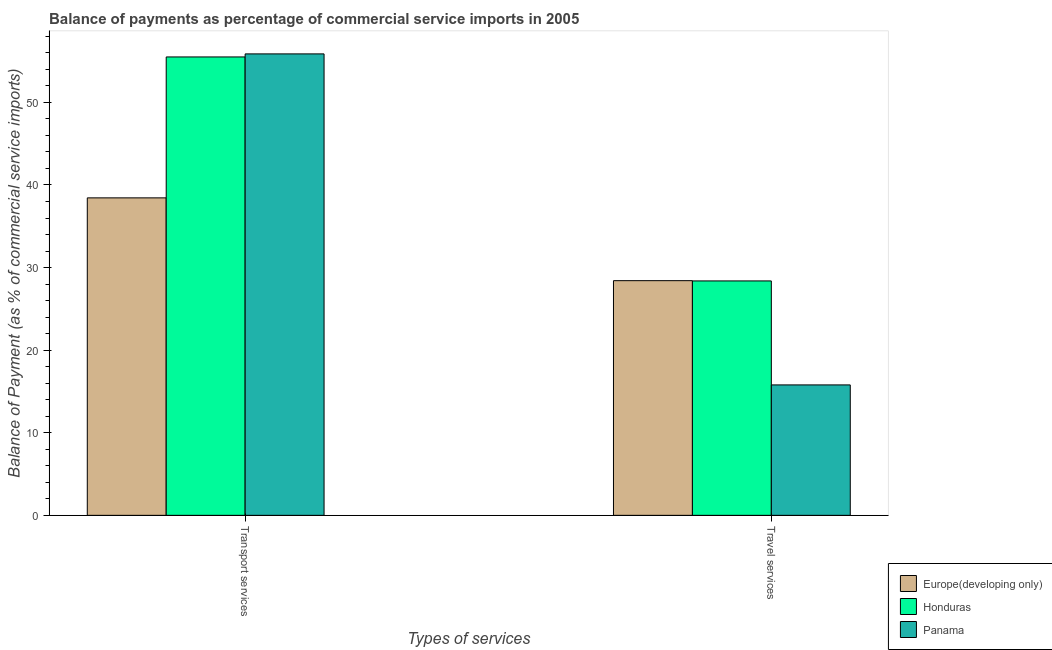How many different coloured bars are there?
Your answer should be compact. 3. Are the number of bars per tick equal to the number of legend labels?
Keep it short and to the point. Yes. Are the number of bars on each tick of the X-axis equal?
Your response must be concise. Yes. How many bars are there on the 2nd tick from the left?
Ensure brevity in your answer.  3. How many bars are there on the 1st tick from the right?
Provide a succinct answer. 3. What is the label of the 1st group of bars from the left?
Your answer should be compact. Transport services. What is the balance of payments of travel services in Panama?
Provide a short and direct response. 15.79. Across all countries, what is the maximum balance of payments of transport services?
Your answer should be very brief. 55.87. Across all countries, what is the minimum balance of payments of transport services?
Your response must be concise. 38.44. In which country was the balance of payments of travel services maximum?
Ensure brevity in your answer.  Europe(developing only). In which country was the balance of payments of transport services minimum?
Keep it short and to the point. Europe(developing only). What is the total balance of payments of travel services in the graph?
Your answer should be very brief. 72.59. What is the difference between the balance of payments of transport services in Europe(developing only) and that in Panama?
Your response must be concise. -17.43. What is the difference between the balance of payments of travel services in Europe(developing only) and the balance of payments of transport services in Honduras?
Your answer should be compact. -27.09. What is the average balance of payments of transport services per country?
Ensure brevity in your answer.  49.94. What is the difference between the balance of payments of travel services and balance of payments of transport services in Panama?
Give a very brief answer. -40.08. What is the ratio of the balance of payments of travel services in Panama to that in Honduras?
Your response must be concise. 0.56. Is the balance of payments of travel services in Europe(developing only) less than that in Honduras?
Your response must be concise. No. In how many countries, is the balance of payments of travel services greater than the average balance of payments of travel services taken over all countries?
Your answer should be very brief. 2. What does the 1st bar from the left in Transport services represents?
Provide a succinct answer. Europe(developing only). What does the 3rd bar from the right in Transport services represents?
Your response must be concise. Europe(developing only). Are all the bars in the graph horizontal?
Offer a terse response. No. How many countries are there in the graph?
Your response must be concise. 3. What is the difference between two consecutive major ticks on the Y-axis?
Provide a short and direct response. 10. Does the graph contain any zero values?
Offer a terse response. No. Does the graph contain grids?
Your answer should be very brief. No. How are the legend labels stacked?
Offer a terse response. Vertical. What is the title of the graph?
Offer a very short reply. Balance of payments as percentage of commercial service imports in 2005. What is the label or title of the X-axis?
Your answer should be very brief. Types of services. What is the label or title of the Y-axis?
Make the answer very short. Balance of Payment (as % of commercial service imports). What is the Balance of Payment (as % of commercial service imports) of Europe(developing only) in Transport services?
Your answer should be compact. 38.44. What is the Balance of Payment (as % of commercial service imports) of Honduras in Transport services?
Your response must be concise. 55.5. What is the Balance of Payment (as % of commercial service imports) in Panama in Transport services?
Ensure brevity in your answer.  55.87. What is the Balance of Payment (as % of commercial service imports) in Europe(developing only) in Travel services?
Give a very brief answer. 28.42. What is the Balance of Payment (as % of commercial service imports) of Honduras in Travel services?
Offer a terse response. 28.38. What is the Balance of Payment (as % of commercial service imports) in Panama in Travel services?
Give a very brief answer. 15.79. Across all Types of services, what is the maximum Balance of Payment (as % of commercial service imports) in Europe(developing only)?
Offer a terse response. 38.44. Across all Types of services, what is the maximum Balance of Payment (as % of commercial service imports) in Honduras?
Give a very brief answer. 55.5. Across all Types of services, what is the maximum Balance of Payment (as % of commercial service imports) of Panama?
Your answer should be very brief. 55.87. Across all Types of services, what is the minimum Balance of Payment (as % of commercial service imports) of Europe(developing only)?
Your response must be concise. 28.42. Across all Types of services, what is the minimum Balance of Payment (as % of commercial service imports) in Honduras?
Your answer should be very brief. 28.38. Across all Types of services, what is the minimum Balance of Payment (as % of commercial service imports) in Panama?
Keep it short and to the point. 15.79. What is the total Balance of Payment (as % of commercial service imports) in Europe(developing only) in the graph?
Your response must be concise. 66.86. What is the total Balance of Payment (as % of commercial service imports) in Honduras in the graph?
Offer a very short reply. 83.89. What is the total Balance of Payment (as % of commercial service imports) in Panama in the graph?
Make the answer very short. 71.66. What is the difference between the Balance of Payment (as % of commercial service imports) of Europe(developing only) in Transport services and that in Travel services?
Give a very brief answer. 10.03. What is the difference between the Balance of Payment (as % of commercial service imports) of Honduras in Transport services and that in Travel services?
Keep it short and to the point. 27.12. What is the difference between the Balance of Payment (as % of commercial service imports) of Panama in Transport services and that in Travel services?
Give a very brief answer. 40.08. What is the difference between the Balance of Payment (as % of commercial service imports) of Europe(developing only) in Transport services and the Balance of Payment (as % of commercial service imports) of Honduras in Travel services?
Provide a short and direct response. 10.06. What is the difference between the Balance of Payment (as % of commercial service imports) of Europe(developing only) in Transport services and the Balance of Payment (as % of commercial service imports) of Panama in Travel services?
Ensure brevity in your answer.  22.65. What is the difference between the Balance of Payment (as % of commercial service imports) in Honduras in Transport services and the Balance of Payment (as % of commercial service imports) in Panama in Travel services?
Give a very brief answer. 39.71. What is the average Balance of Payment (as % of commercial service imports) in Europe(developing only) per Types of services?
Offer a terse response. 33.43. What is the average Balance of Payment (as % of commercial service imports) of Honduras per Types of services?
Your answer should be compact. 41.94. What is the average Balance of Payment (as % of commercial service imports) of Panama per Types of services?
Ensure brevity in your answer.  35.83. What is the difference between the Balance of Payment (as % of commercial service imports) in Europe(developing only) and Balance of Payment (as % of commercial service imports) in Honduras in Transport services?
Ensure brevity in your answer.  -17.06. What is the difference between the Balance of Payment (as % of commercial service imports) of Europe(developing only) and Balance of Payment (as % of commercial service imports) of Panama in Transport services?
Provide a succinct answer. -17.43. What is the difference between the Balance of Payment (as % of commercial service imports) in Honduras and Balance of Payment (as % of commercial service imports) in Panama in Transport services?
Provide a short and direct response. -0.37. What is the difference between the Balance of Payment (as % of commercial service imports) in Europe(developing only) and Balance of Payment (as % of commercial service imports) in Honduras in Travel services?
Ensure brevity in your answer.  0.03. What is the difference between the Balance of Payment (as % of commercial service imports) of Europe(developing only) and Balance of Payment (as % of commercial service imports) of Panama in Travel services?
Your answer should be compact. 12.62. What is the difference between the Balance of Payment (as % of commercial service imports) of Honduras and Balance of Payment (as % of commercial service imports) of Panama in Travel services?
Provide a succinct answer. 12.59. What is the ratio of the Balance of Payment (as % of commercial service imports) of Europe(developing only) in Transport services to that in Travel services?
Make the answer very short. 1.35. What is the ratio of the Balance of Payment (as % of commercial service imports) of Honduras in Transport services to that in Travel services?
Your answer should be compact. 1.96. What is the ratio of the Balance of Payment (as % of commercial service imports) of Panama in Transport services to that in Travel services?
Provide a succinct answer. 3.54. What is the difference between the highest and the second highest Balance of Payment (as % of commercial service imports) in Europe(developing only)?
Offer a terse response. 10.03. What is the difference between the highest and the second highest Balance of Payment (as % of commercial service imports) in Honduras?
Make the answer very short. 27.12. What is the difference between the highest and the second highest Balance of Payment (as % of commercial service imports) of Panama?
Your answer should be very brief. 40.08. What is the difference between the highest and the lowest Balance of Payment (as % of commercial service imports) in Europe(developing only)?
Give a very brief answer. 10.03. What is the difference between the highest and the lowest Balance of Payment (as % of commercial service imports) of Honduras?
Keep it short and to the point. 27.12. What is the difference between the highest and the lowest Balance of Payment (as % of commercial service imports) of Panama?
Provide a short and direct response. 40.08. 